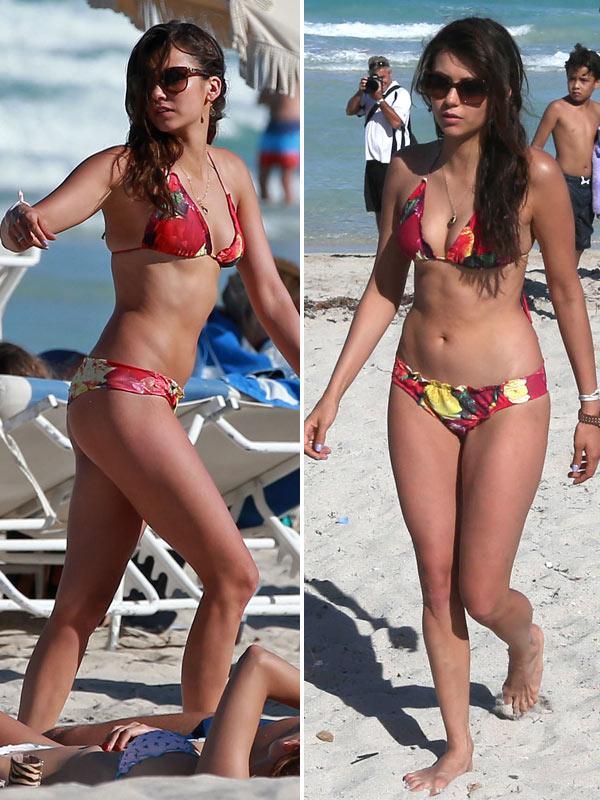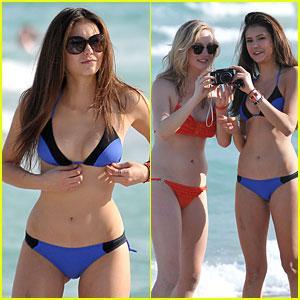The first image is the image on the left, the second image is the image on the right. Given the left and right images, does the statement "There are two women wearing swimsuits in the image on the left." hold true? Answer yes or no. Yes. The first image is the image on the left, the second image is the image on the right. For the images shown, is this caption "The right image shows a woman in a red bikini top and a woman in a blue bikini top looking at a camera together" true? Answer yes or no. Yes. 